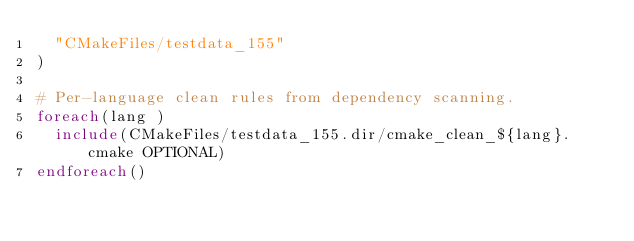<code> <loc_0><loc_0><loc_500><loc_500><_CMake_>  "CMakeFiles/testdata_155"
)

# Per-language clean rules from dependency scanning.
foreach(lang )
  include(CMakeFiles/testdata_155.dir/cmake_clean_${lang}.cmake OPTIONAL)
endforeach()
</code> 